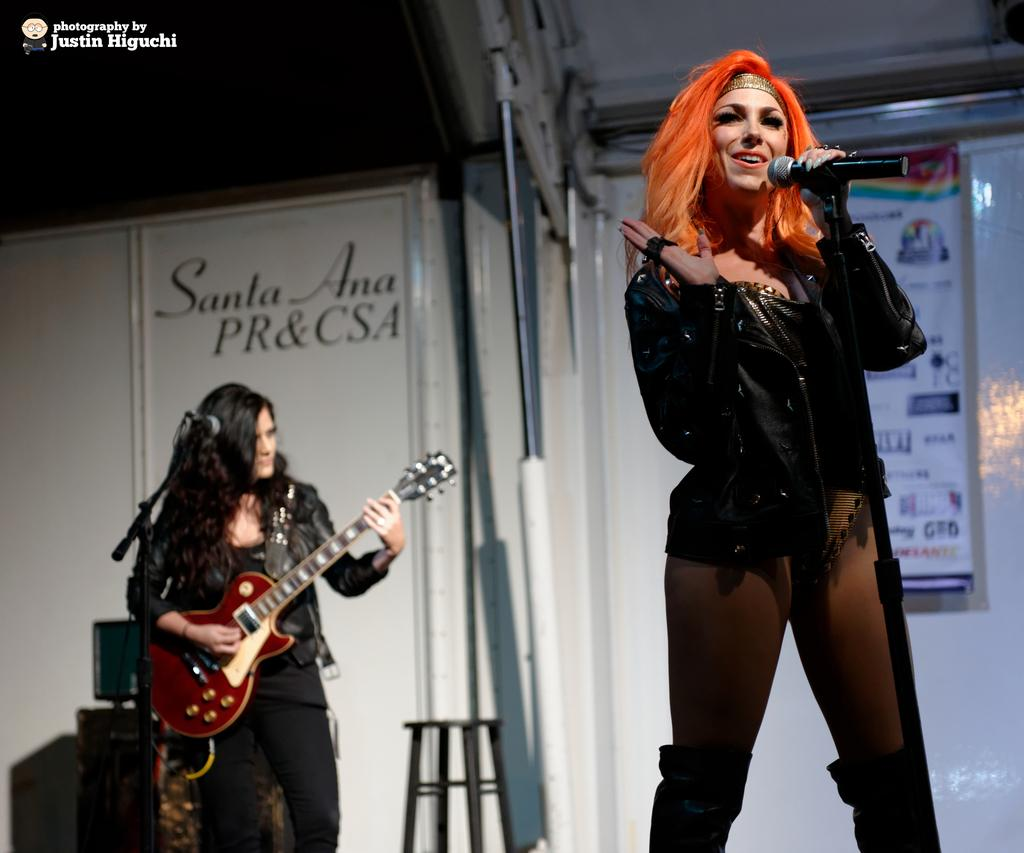How many women are present in the image? There are two women standing in the image. What are the women doing in the image? One woman is singing a song, and the other woman is playing an object, possibly a musical instrument. What can be seen in the background of the image? There is a white color wall in the background of the image. What type of stocking is the queen wearing in the image? There is no queen or stocking present in the image. Is there a patch on the wall in the image? There is no patch mentioned or visible in the image; only a white color wall is described. 